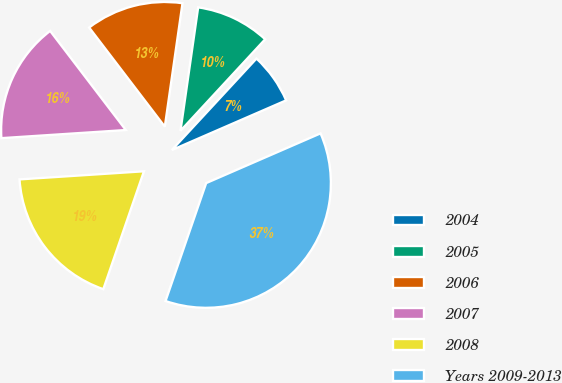Convert chart. <chart><loc_0><loc_0><loc_500><loc_500><pie_chart><fcel>2004<fcel>2005<fcel>2006<fcel>2007<fcel>2008<fcel>Years 2009-2013<nl><fcel>6.59%<fcel>9.62%<fcel>12.64%<fcel>15.66%<fcel>18.68%<fcel>36.81%<nl></chart> 